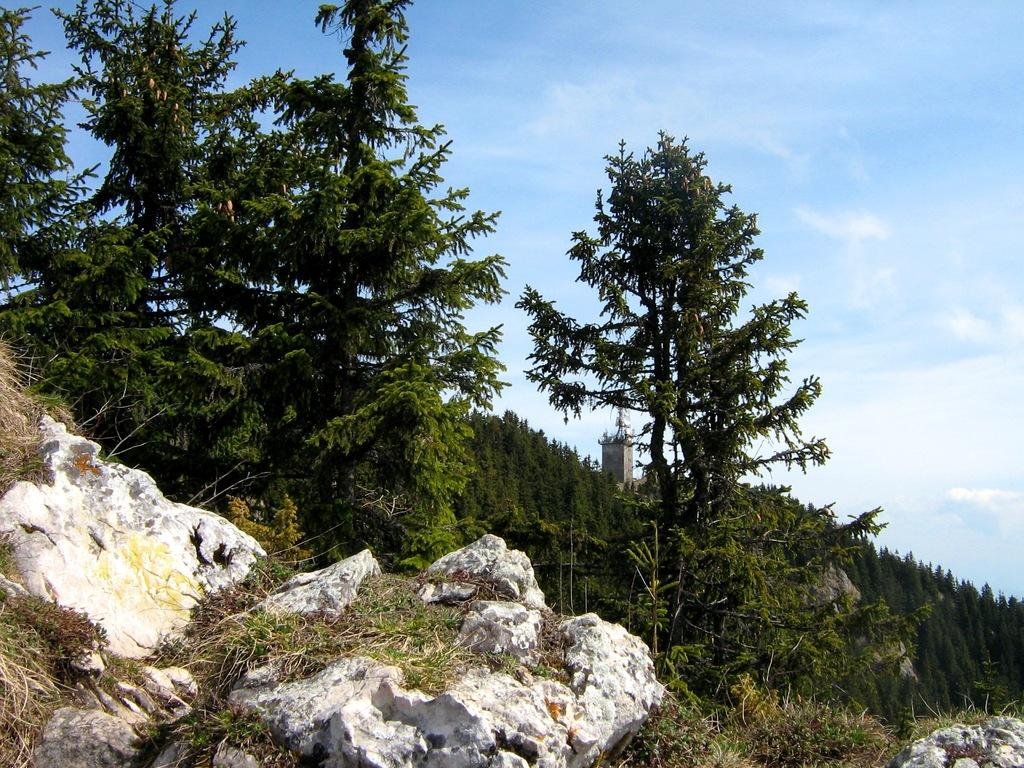What type of natural elements can be seen in the image? There are rocks, grass, and trees in the image. What type of structure is visible in the background of the image? There is a building in the background of the image. What is visible at the top of the image? The sky is visible at the top of the image. What type of brass instrument is being played by the rocks in the image? There is no brass instrument or rocks playing an instrument in the image. 